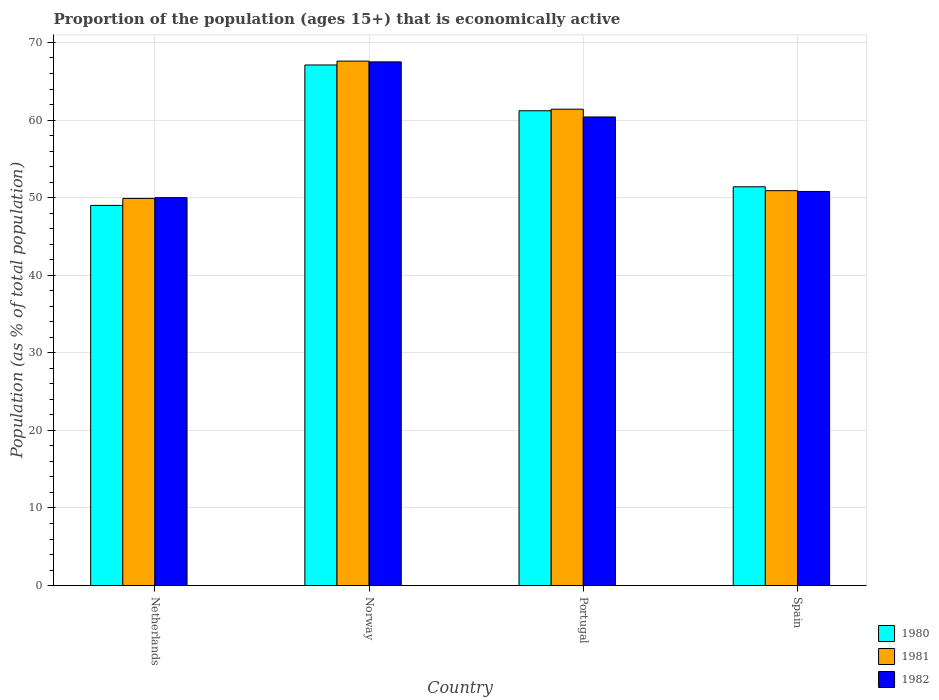How many groups of bars are there?
Provide a short and direct response. 4. Are the number of bars per tick equal to the number of legend labels?
Give a very brief answer. Yes. How many bars are there on the 2nd tick from the left?
Provide a short and direct response. 3. What is the proportion of the population that is economically active in 1980 in Spain?
Make the answer very short. 51.4. Across all countries, what is the maximum proportion of the population that is economically active in 1980?
Keep it short and to the point. 67.1. Across all countries, what is the minimum proportion of the population that is economically active in 1982?
Offer a very short reply. 50. In which country was the proportion of the population that is economically active in 1982 minimum?
Provide a short and direct response. Netherlands. What is the total proportion of the population that is economically active in 1982 in the graph?
Make the answer very short. 228.7. What is the difference between the proportion of the population that is economically active in 1982 in Portugal and that in Spain?
Your response must be concise. 9.6. What is the difference between the proportion of the population that is economically active in 1981 in Norway and the proportion of the population that is economically active in 1980 in Netherlands?
Offer a terse response. 18.6. What is the average proportion of the population that is economically active in 1981 per country?
Offer a terse response. 57.45. What is the ratio of the proportion of the population that is economically active in 1982 in Portugal to that in Spain?
Make the answer very short. 1.19. What is the difference between the highest and the second highest proportion of the population that is economically active in 1980?
Make the answer very short. -15.7. What does the 1st bar from the left in Norway represents?
Provide a succinct answer. 1980. What does the 2nd bar from the right in Portugal represents?
Your answer should be very brief. 1981. Is it the case that in every country, the sum of the proportion of the population that is economically active in 1981 and proportion of the population that is economically active in 1982 is greater than the proportion of the population that is economically active in 1980?
Your response must be concise. Yes. Are all the bars in the graph horizontal?
Your response must be concise. No. How many countries are there in the graph?
Your answer should be compact. 4. Are the values on the major ticks of Y-axis written in scientific E-notation?
Your answer should be very brief. No. Does the graph contain any zero values?
Your answer should be compact. No. Does the graph contain grids?
Your answer should be very brief. Yes. How many legend labels are there?
Keep it short and to the point. 3. How are the legend labels stacked?
Your answer should be very brief. Vertical. What is the title of the graph?
Ensure brevity in your answer.  Proportion of the population (ages 15+) that is economically active. What is the label or title of the X-axis?
Offer a very short reply. Country. What is the label or title of the Y-axis?
Provide a succinct answer. Population (as % of total population). What is the Population (as % of total population) in 1981 in Netherlands?
Ensure brevity in your answer.  49.9. What is the Population (as % of total population) in 1982 in Netherlands?
Provide a short and direct response. 50. What is the Population (as % of total population) in 1980 in Norway?
Keep it short and to the point. 67.1. What is the Population (as % of total population) of 1981 in Norway?
Your response must be concise. 67.6. What is the Population (as % of total population) of 1982 in Norway?
Offer a very short reply. 67.5. What is the Population (as % of total population) of 1980 in Portugal?
Your answer should be very brief. 61.2. What is the Population (as % of total population) in 1981 in Portugal?
Your answer should be compact. 61.4. What is the Population (as % of total population) of 1982 in Portugal?
Provide a succinct answer. 60.4. What is the Population (as % of total population) of 1980 in Spain?
Keep it short and to the point. 51.4. What is the Population (as % of total population) of 1981 in Spain?
Keep it short and to the point. 50.9. What is the Population (as % of total population) of 1982 in Spain?
Give a very brief answer. 50.8. Across all countries, what is the maximum Population (as % of total population) of 1980?
Make the answer very short. 67.1. Across all countries, what is the maximum Population (as % of total population) of 1981?
Your response must be concise. 67.6. Across all countries, what is the maximum Population (as % of total population) in 1982?
Give a very brief answer. 67.5. Across all countries, what is the minimum Population (as % of total population) of 1981?
Make the answer very short. 49.9. What is the total Population (as % of total population) in 1980 in the graph?
Keep it short and to the point. 228.7. What is the total Population (as % of total population) in 1981 in the graph?
Offer a very short reply. 229.8. What is the total Population (as % of total population) in 1982 in the graph?
Give a very brief answer. 228.7. What is the difference between the Population (as % of total population) in 1980 in Netherlands and that in Norway?
Provide a short and direct response. -18.1. What is the difference between the Population (as % of total population) in 1981 in Netherlands and that in Norway?
Provide a succinct answer. -17.7. What is the difference between the Population (as % of total population) of 1982 in Netherlands and that in Norway?
Your answer should be compact. -17.5. What is the difference between the Population (as % of total population) in 1980 in Netherlands and that in Portugal?
Offer a terse response. -12.2. What is the difference between the Population (as % of total population) of 1981 in Netherlands and that in Portugal?
Your answer should be compact. -11.5. What is the difference between the Population (as % of total population) of 1982 in Netherlands and that in Portugal?
Provide a short and direct response. -10.4. What is the difference between the Population (as % of total population) in 1980 in Netherlands and that in Spain?
Your answer should be very brief. -2.4. What is the difference between the Population (as % of total population) in 1980 in Norway and that in Spain?
Provide a succinct answer. 15.7. What is the difference between the Population (as % of total population) in 1981 in Norway and that in Spain?
Make the answer very short. 16.7. What is the difference between the Population (as % of total population) of 1982 in Norway and that in Spain?
Offer a terse response. 16.7. What is the difference between the Population (as % of total population) of 1981 in Portugal and that in Spain?
Make the answer very short. 10.5. What is the difference between the Population (as % of total population) in 1982 in Portugal and that in Spain?
Your answer should be very brief. 9.6. What is the difference between the Population (as % of total population) in 1980 in Netherlands and the Population (as % of total population) in 1981 in Norway?
Provide a short and direct response. -18.6. What is the difference between the Population (as % of total population) of 1980 in Netherlands and the Population (as % of total population) of 1982 in Norway?
Your response must be concise. -18.5. What is the difference between the Population (as % of total population) of 1981 in Netherlands and the Population (as % of total population) of 1982 in Norway?
Keep it short and to the point. -17.6. What is the difference between the Population (as % of total population) in 1980 in Netherlands and the Population (as % of total population) in 1981 in Portugal?
Provide a succinct answer. -12.4. What is the difference between the Population (as % of total population) of 1980 in Netherlands and the Population (as % of total population) of 1982 in Portugal?
Ensure brevity in your answer.  -11.4. What is the difference between the Population (as % of total population) of 1981 in Netherlands and the Population (as % of total population) of 1982 in Portugal?
Make the answer very short. -10.5. What is the difference between the Population (as % of total population) of 1980 in Netherlands and the Population (as % of total population) of 1981 in Spain?
Give a very brief answer. -1.9. What is the difference between the Population (as % of total population) in 1980 in Netherlands and the Population (as % of total population) in 1982 in Spain?
Give a very brief answer. -1.8. What is the difference between the Population (as % of total population) of 1981 in Netherlands and the Population (as % of total population) of 1982 in Spain?
Your response must be concise. -0.9. What is the difference between the Population (as % of total population) of 1980 in Norway and the Population (as % of total population) of 1982 in Portugal?
Keep it short and to the point. 6.7. What is the difference between the Population (as % of total population) of 1981 in Norway and the Population (as % of total population) of 1982 in Portugal?
Provide a short and direct response. 7.2. What is the difference between the Population (as % of total population) of 1980 in Norway and the Population (as % of total population) of 1981 in Spain?
Give a very brief answer. 16.2. What is the difference between the Population (as % of total population) in 1980 in Portugal and the Population (as % of total population) in 1982 in Spain?
Provide a short and direct response. 10.4. What is the average Population (as % of total population) of 1980 per country?
Your response must be concise. 57.17. What is the average Population (as % of total population) of 1981 per country?
Give a very brief answer. 57.45. What is the average Population (as % of total population) of 1982 per country?
Keep it short and to the point. 57.17. What is the difference between the Population (as % of total population) in 1980 and Population (as % of total population) in 1981 in Netherlands?
Provide a short and direct response. -0.9. What is the difference between the Population (as % of total population) in 1980 and Population (as % of total population) in 1982 in Netherlands?
Offer a very short reply. -1. What is the difference between the Population (as % of total population) of 1981 and Population (as % of total population) of 1982 in Norway?
Make the answer very short. 0.1. What is the difference between the Population (as % of total population) of 1981 and Population (as % of total population) of 1982 in Portugal?
Give a very brief answer. 1. What is the difference between the Population (as % of total population) in 1980 and Population (as % of total population) in 1981 in Spain?
Provide a short and direct response. 0.5. What is the difference between the Population (as % of total population) in 1981 and Population (as % of total population) in 1982 in Spain?
Your answer should be very brief. 0.1. What is the ratio of the Population (as % of total population) of 1980 in Netherlands to that in Norway?
Provide a succinct answer. 0.73. What is the ratio of the Population (as % of total population) of 1981 in Netherlands to that in Norway?
Your answer should be compact. 0.74. What is the ratio of the Population (as % of total population) in 1982 in Netherlands to that in Norway?
Give a very brief answer. 0.74. What is the ratio of the Population (as % of total population) in 1980 in Netherlands to that in Portugal?
Provide a succinct answer. 0.8. What is the ratio of the Population (as % of total population) of 1981 in Netherlands to that in Portugal?
Your answer should be compact. 0.81. What is the ratio of the Population (as % of total population) in 1982 in Netherlands to that in Portugal?
Provide a short and direct response. 0.83. What is the ratio of the Population (as % of total population) in 1980 in Netherlands to that in Spain?
Provide a short and direct response. 0.95. What is the ratio of the Population (as % of total population) in 1981 in Netherlands to that in Spain?
Give a very brief answer. 0.98. What is the ratio of the Population (as % of total population) in 1982 in Netherlands to that in Spain?
Give a very brief answer. 0.98. What is the ratio of the Population (as % of total population) in 1980 in Norway to that in Portugal?
Provide a short and direct response. 1.1. What is the ratio of the Population (as % of total population) of 1981 in Norway to that in Portugal?
Give a very brief answer. 1.1. What is the ratio of the Population (as % of total population) of 1982 in Norway to that in Portugal?
Give a very brief answer. 1.12. What is the ratio of the Population (as % of total population) in 1980 in Norway to that in Spain?
Give a very brief answer. 1.31. What is the ratio of the Population (as % of total population) of 1981 in Norway to that in Spain?
Your response must be concise. 1.33. What is the ratio of the Population (as % of total population) of 1982 in Norway to that in Spain?
Offer a very short reply. 1.33. What is the ratio of the Population (as % of total population) of 1980 in Portugal to that in Spain?
Ensure brevity in your answer.  1.19. What is the ratio of the Population (as % of total population) in 1981 in Portugal to that in Spain?
Your answer should be compact. 1.21. What is the ratio of the Population (as % of total population) of 1982 in Portugal to that in Spain?
Your response must be concise. 1.19. What is the difference between the highest and the second highest Population (as % of total population) of 1981?
Provide a short and direct response. 6.2. What is the difference between the highest and the lowest Population (as % of total population) of 1980?
Give a very brief answer. 18.1. What is the difference between the highest and the lowest Population (as % of total population) in 1981?
Ensure brevity in your answer.  17.7. What is the difference between the highest and the lowest Population (as % of total population) in 1982?
Your answer should be very brief. 17.5. 